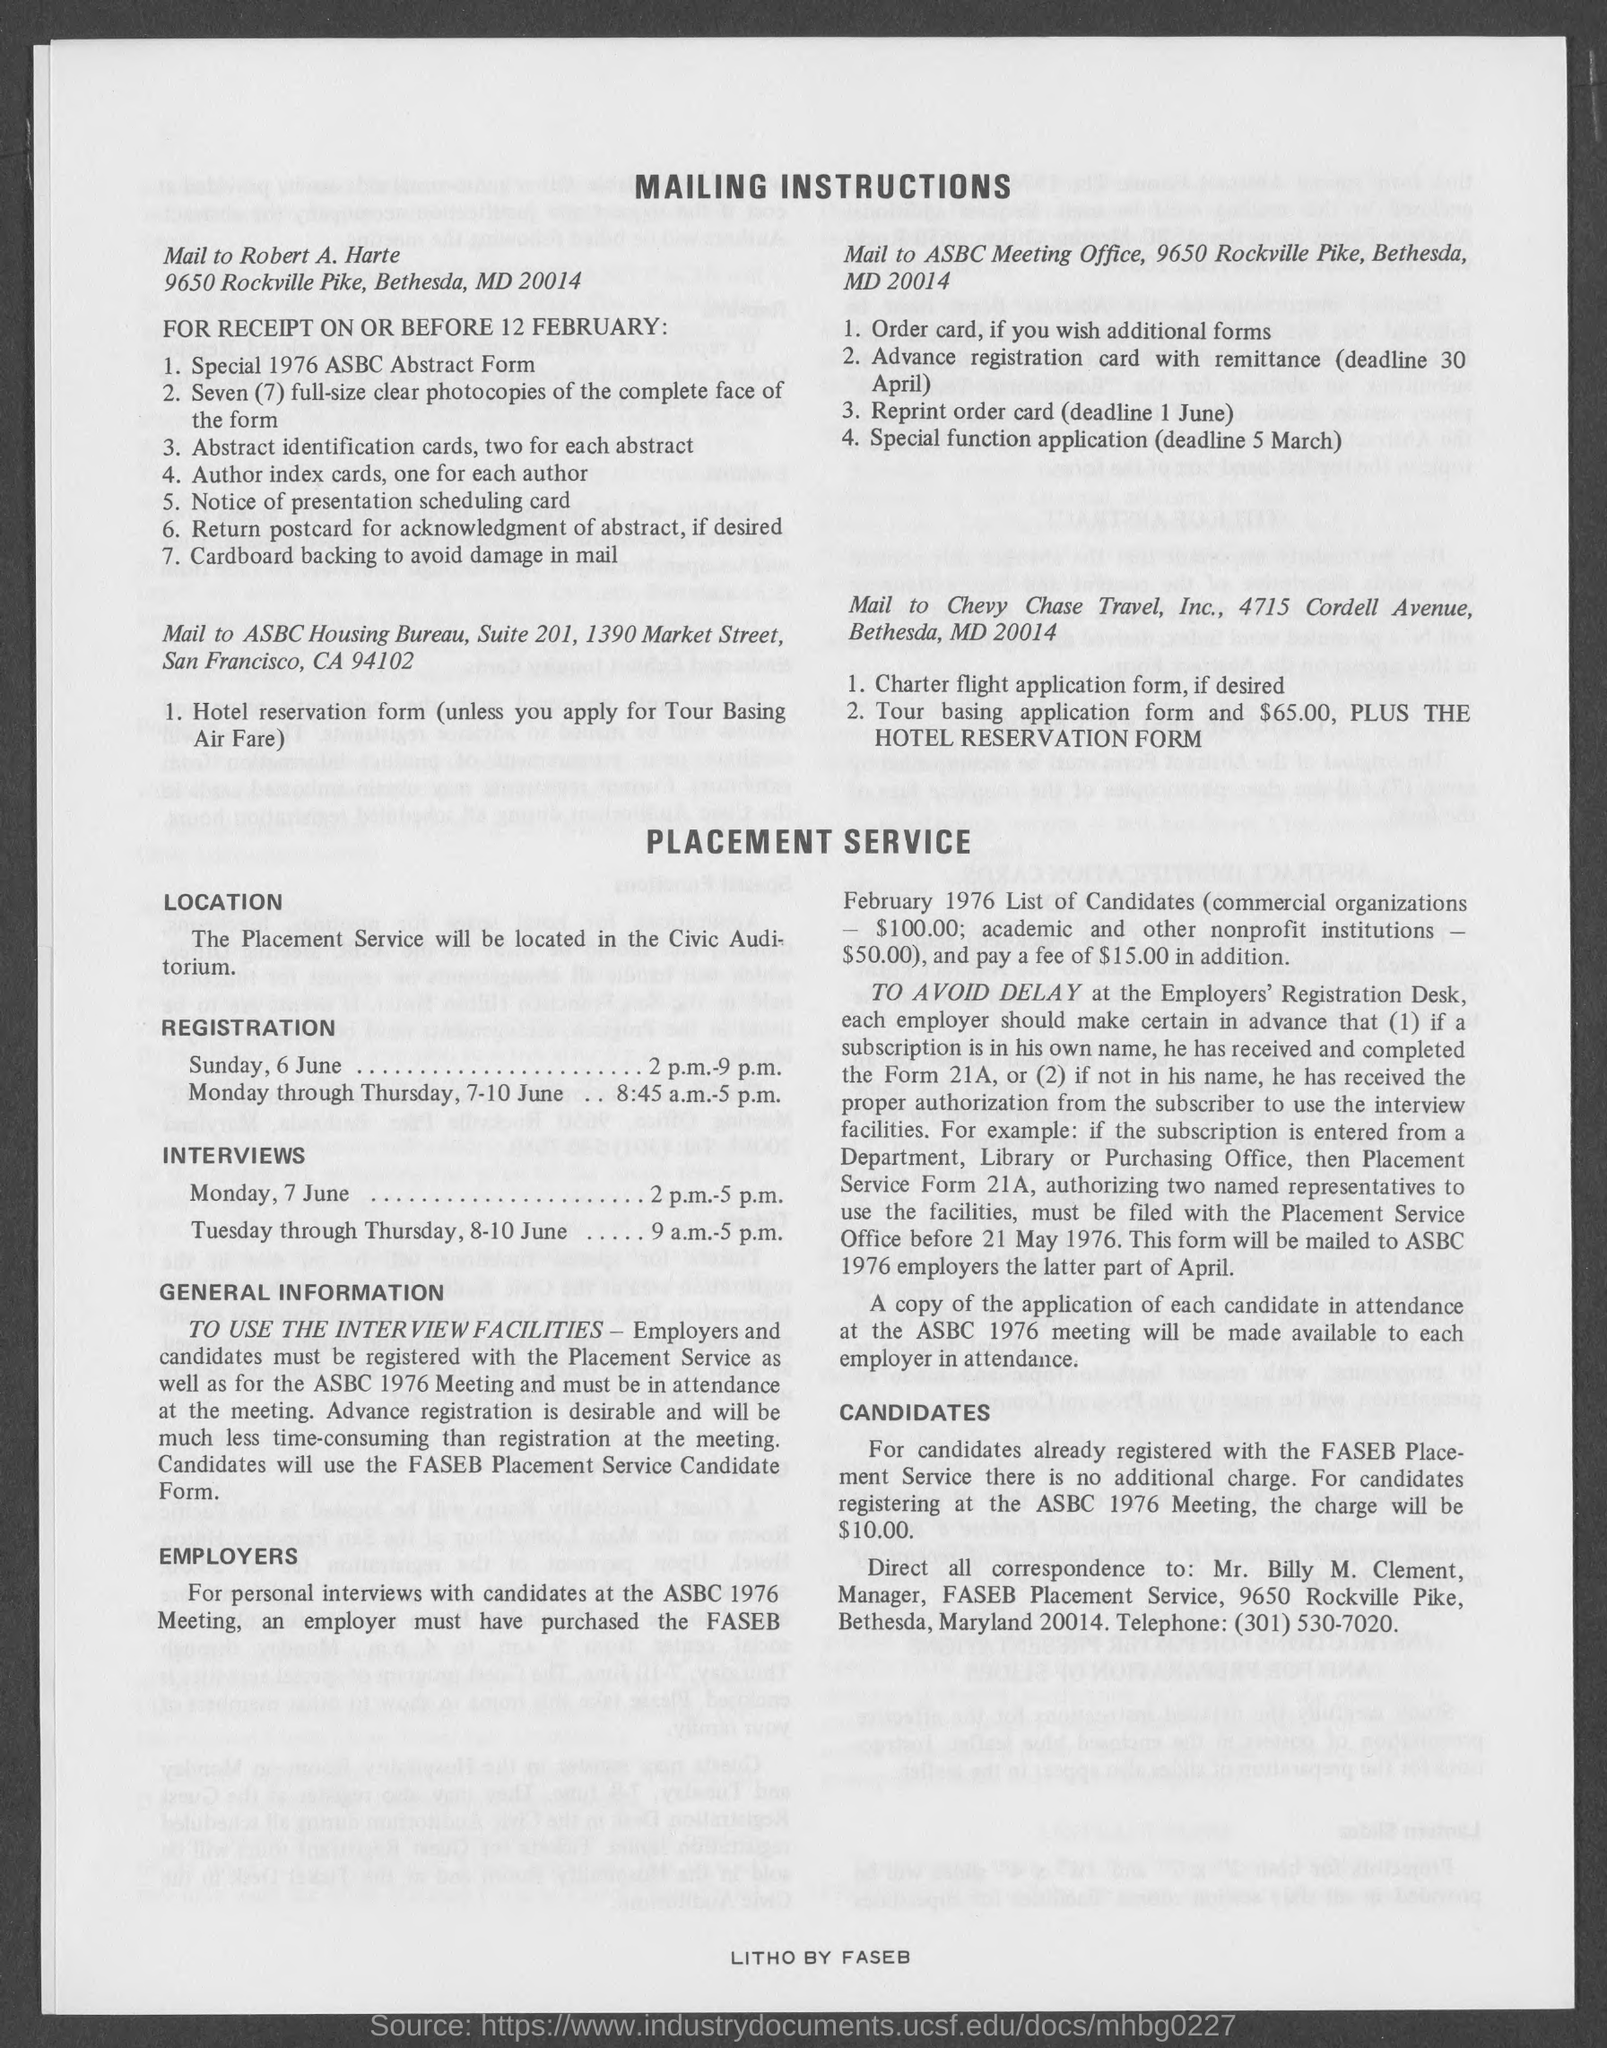What is the Title of the document?
Give a very brief answer. Mailing Instructions. Where is the Placement service located?
Offer a very short reply. In the civic auditorium. 